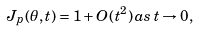Convert formula to latex. <formula><loc_0><loc_0><loc_500><loc_500>J _ { p } ( \theta , t ) = 1 + O ( t ^ { 2 } ) \, a s \, t \rightarrow 0 ,</formula> 